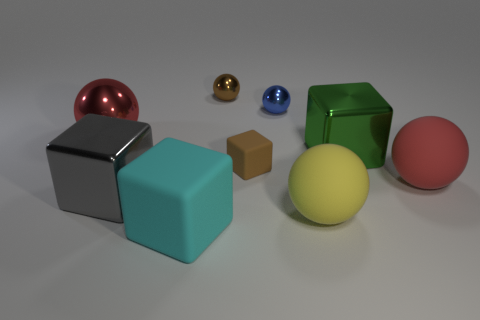Add 1 large gray matte things. How many objects exist? 10 Subtract all big shiny balls. How many balls are left? 4 Subtract all blocks. How many objects are left? 5 Subtract all green blocks. How many blocks are left? 3 Subtract 1 cubes. How many cubes are left? 3 Subtract all green blocks. Subtract all blue spheres. How many blocks are left? 3 Subtract all cyan cubes. How many blue balls are left? 1 Subtract all small yellow balls. Subtract all small metal spheres. How many objects are left? 7 Add 9 big red rubber spheres. How many big red rubber spheres are left? 10 Add 1 small blue objects. How many small blue objects exist? 2 